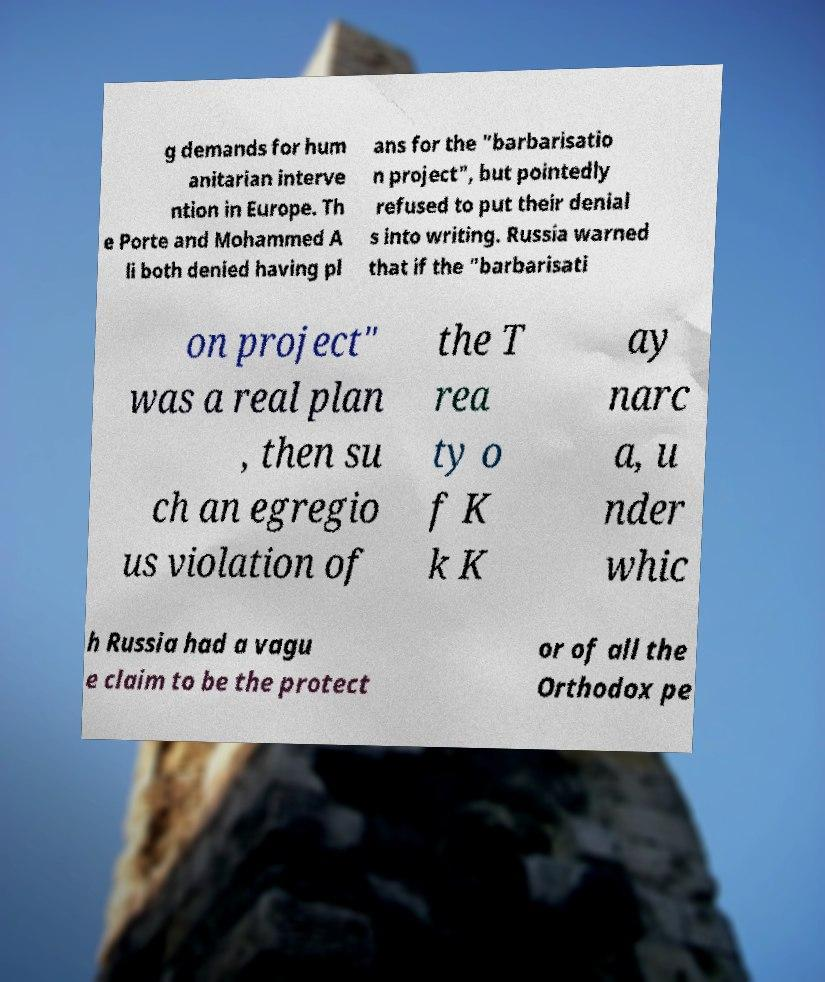Can you read and provide the text displayed in the image?This photo seems to have some interesting text. Can you extract and type it out for me? g demands for hum anitarian interve ntion in Europe. Th e Porte and Mohammed A li both denied having pl ans for the "barbarisatio n project", but pointedly refused to put their denial s into writing. Russia warned that if the "barbarisati on project" was a real plan , then su ch an egregio us violation of the T rea ty o f K k K ay narc a, u nder whic h Russia had a vagu e claim to be the protect or of all the Orthodox pe 